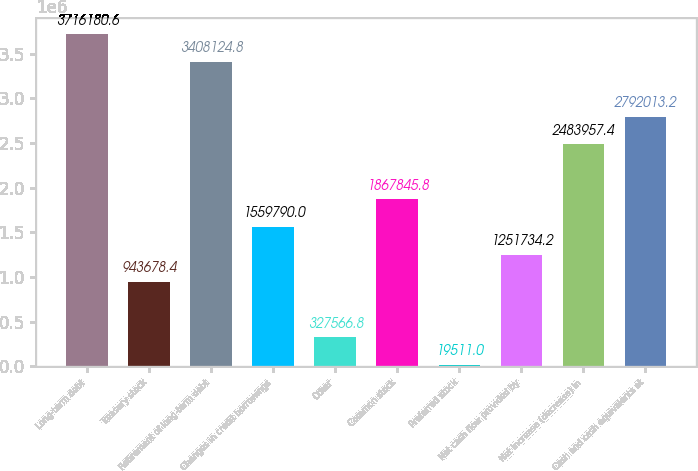Convert chart. <chart><loc_0><loc_0><loc_500><loc_500><bar_chart><fcel>Long-term debt<fcel>Treasury stock<fcel>Retirement of long-term debt<fcel>Changes in credit borrowings<fcel>Other<fcel>Common stock<fcel>Preferred stock<fcel>Net cash flow provided by<fcel>Net increase (decrease) in<fcel>Cash and cash equivalents at<nl><fcel>3.71618e+06<fcel>943678<fcel>3.40812e+06<fcel>1.55979e+06<fcel>327567<fcel>1.86785e+06<fcel>19511<fcel>1.25173e+06<fcel>2.48396e+06<fcel>2.79201e+06<nl></chart> 